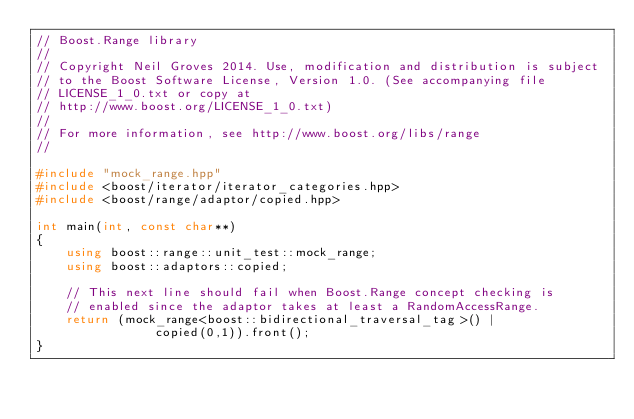Convert code to text. <code><loc_0><loc_0><loc_500><loc_500><_C++_>// Boost.Range library
//
// Copyright Neil Groves 2014. Use, modification and distribution is subject
// to the Boost Software License, Version 1.0. (See accompanying file
// LICENSE_1_0.txt or copy at
// http://www.boost.org/LICENSE_1_0.txt)
//
// For more information, see http://www.boost.org/libs/range
//

#include "mock_range.hpp"
#include <boost/iterator/iterator_categories.hpp>
#include <boost/range/adaptor/copied.hpp>

int main(int, const char**)
{
    using boost::range::unit_test::mock_range;
    using boost::adaptors::copied;

    // This next line should fail when Boost.Range concept checking is
    // enabled since the adaptor takes at least a RandomAccessRange.
    return (mock_range<boost::bidirectional_traversal_tag>() |
                copied(0,1)).front();
}
</code> 